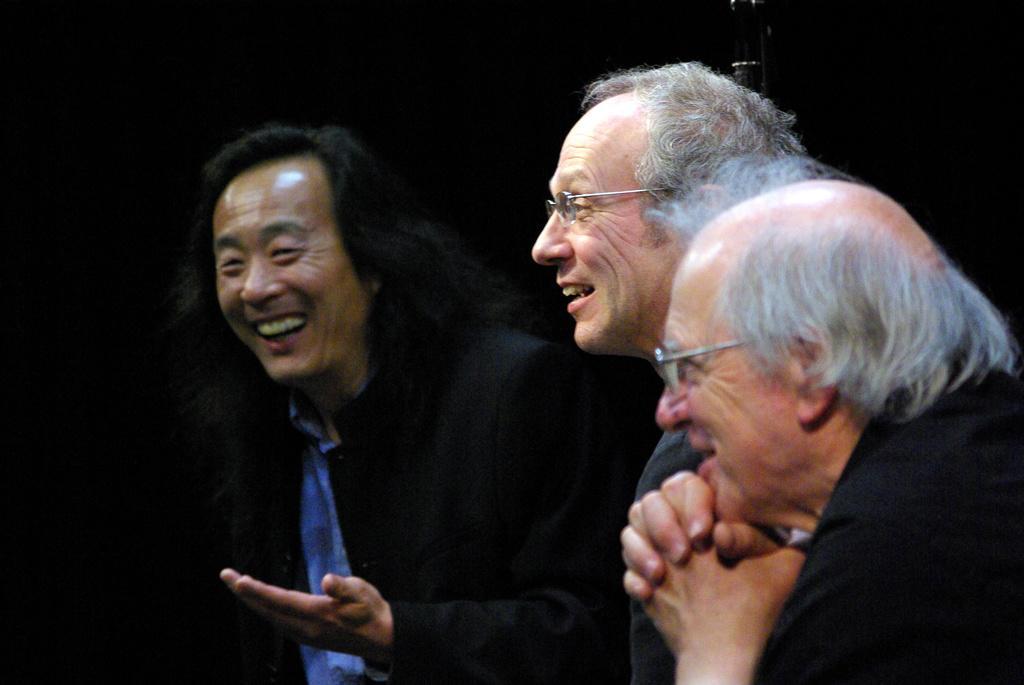In one or two sentences, can you explain what this image depicts? In this image we can see few people. There is an object in the image. There is a dark background in the image. 